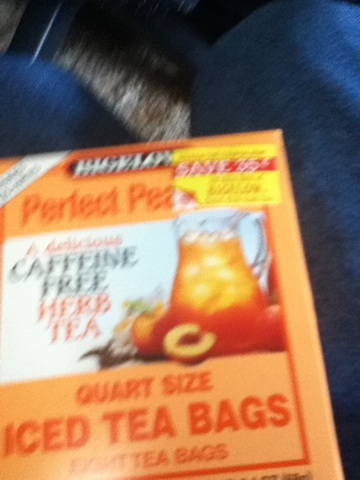What can be paired with this peach iced tea for the perfect summer picnic? The perfect summer picnic paired with Perfect Peach iced tea could include a fresh fruit salad with a mix of berries, melons, and, of course, juicy peaches. Add some cool cucumber sandwiches, a vibrant pasta salad with cherry tomatoes and basil, and some light, crisp veggie sticks with a flavorful hummus dip. For dessert, try some peach cobbler bites or mini fruit tarts to complement the peachy notes of the iced tea. This combination will ensure a refreshing and delightful picnic experience. Tell me a fun fact about iced tea in general. Did you know that iced tea was popularized in the United States at the 1904 World's Fair in St. Louis? Due to the scorching heat, fair visitors were craving cold refreshments. Richard Blechynden, a tea merchant, faced a major challenge as his hot tea wasn't selling. In a moment of ingenuity, he poured the hot tea over ice, creating the first known version of iced tea. It was an instant hit, and since then, iced tea has become a beloved beverage, especially during the hot summer months! 